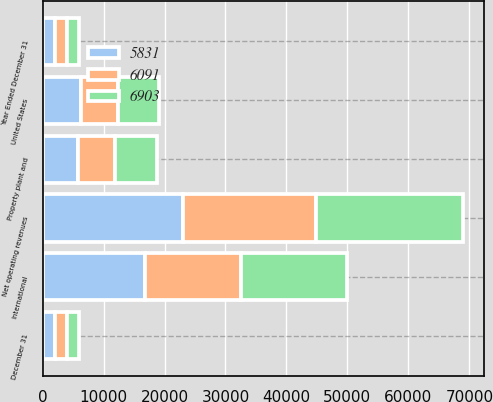Convert chart. <chart><loc_0><loc_0><loc_500><loc_500><stacked_bar_chart><ecel><fcel>Year Ended December 31<fcel>United States<fcel>International<fcel>Net operating revenues<fcel>December 31<fcel>Property plant and<nl><fcel>6903<fcel>2006<fcel>6662<fcel>17426<fcel>24088<fcel>2006<fcel>6903<nl><fcel>5831<fcel>2005<fcel>6299<fcel>16805<fcel>23104<fcel>2005<fcel>5831<nl><fcel>6091<fcel>2004<fcel>6084<fcel>15658<fcel>21742<fcel>2004<fcel>6091<nl></chart> 